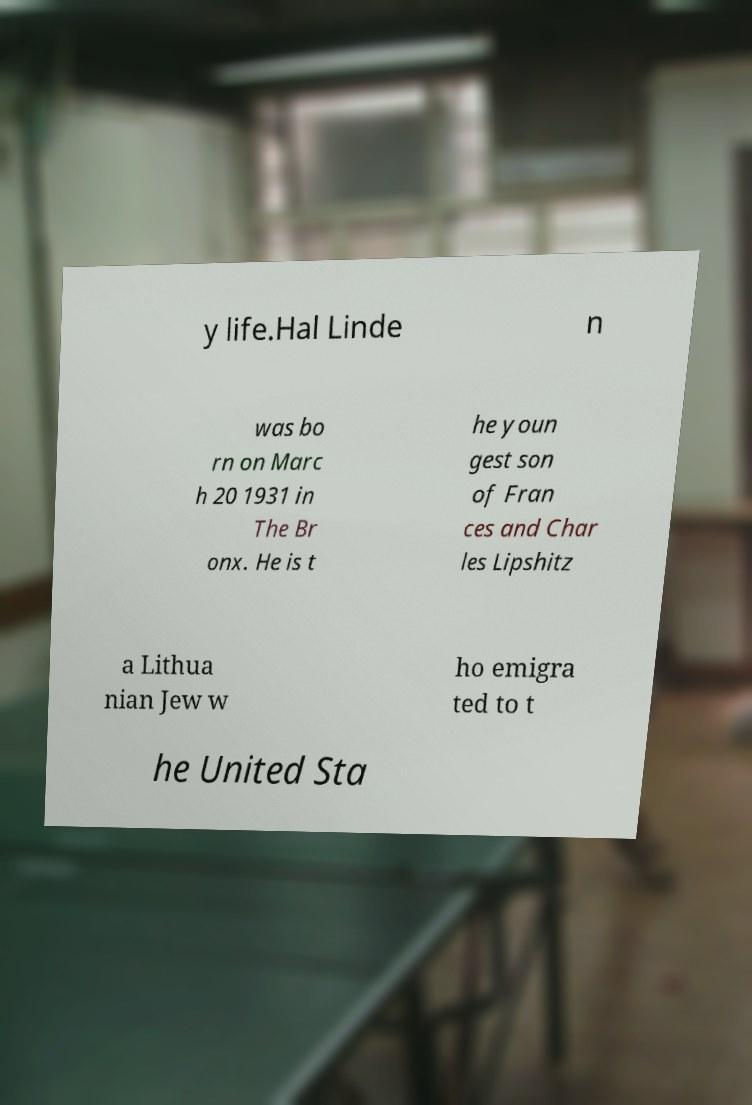Please read and relay the text visible in this image. What does it say? y life.Hal Linde n was bo rn on Marc h 20 1931 in The Br onx. He is t he youn gest son of Fran ces and Char les Lipshitz a Lithua nian Jew w ho emigra ted to t he United Sta 